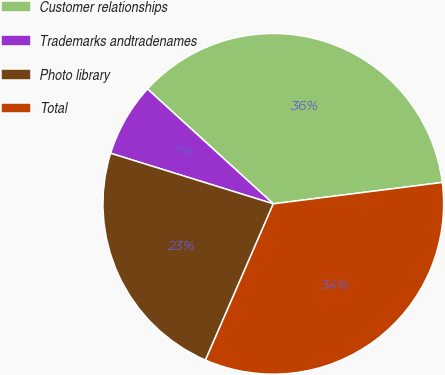Convert chart. <chart><loc_0><loc_0><loc_500><loc_500><pie_chart><fcel>Customer relationships<fcel>Trademarks andtradenames<fcel>Photo library<fcel>Total<nl><fcel>36.22%<fcel>6.98%<fcel>23.28%<fcel>33.52%<nl></chart> 